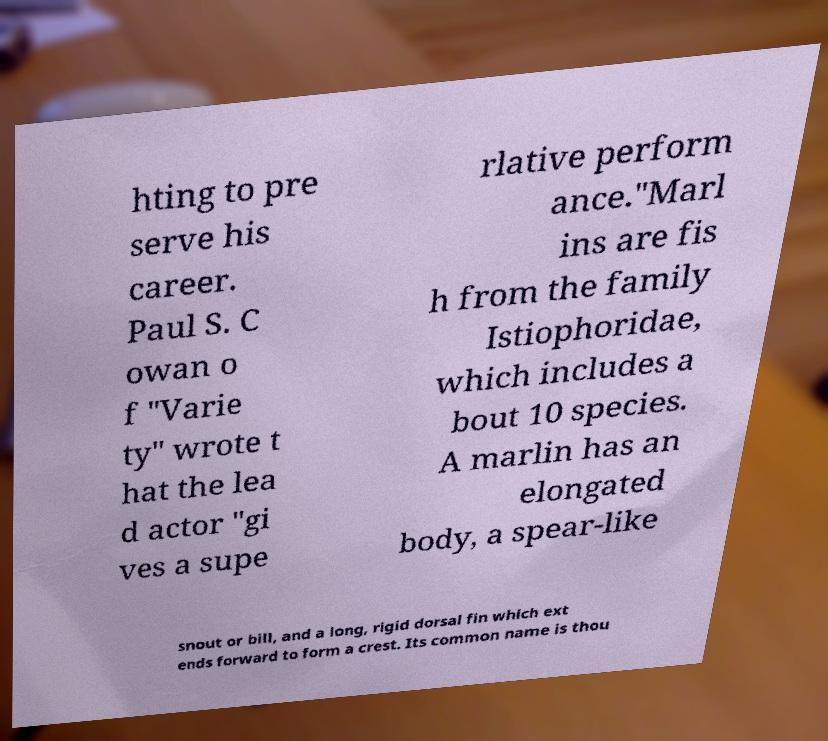Please identify and transcribe the text found in this image. hting to pre serve his career. Paul S. C owan o f "Varie ty" wrote t hat the lea d actor "gi ves a supe rlative perform ance."Marl ins are fis h from the family Istiophoridae, which includes a bout 10 species. A marlin has an elongated body, a spear-like snout or bill, and a long, rigid dorsal fin which ext ends forward to form a crest. Its common name is thou 